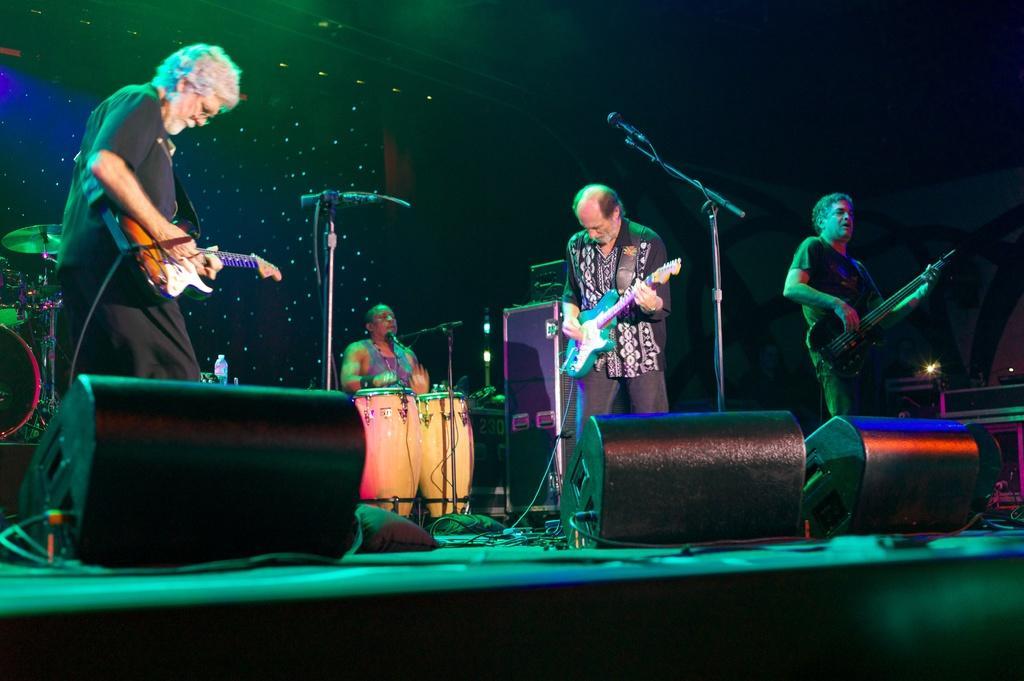In one or two sentences, can you explain what this image depicts? In this picture we can see some people holding some musical instruments and playing them on the stage and there are some speakers on the stage. 